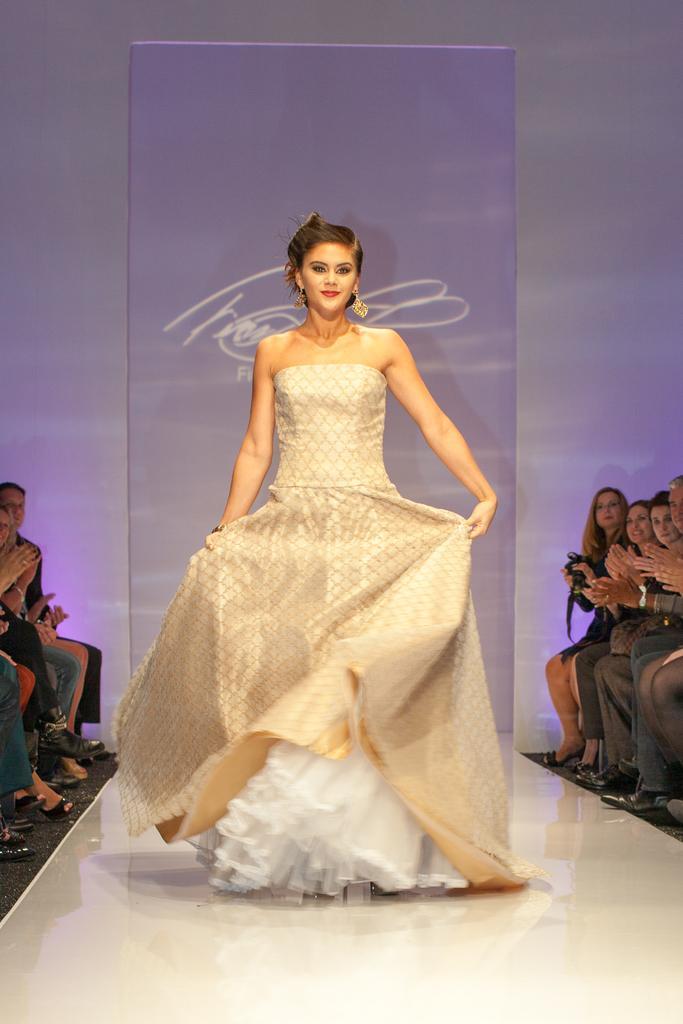Please provide a concise description of this image. This picture shows a woman walking and we see few people seated on the both sides and clapping with their hands and we see a advertisement hoarding on the back. 